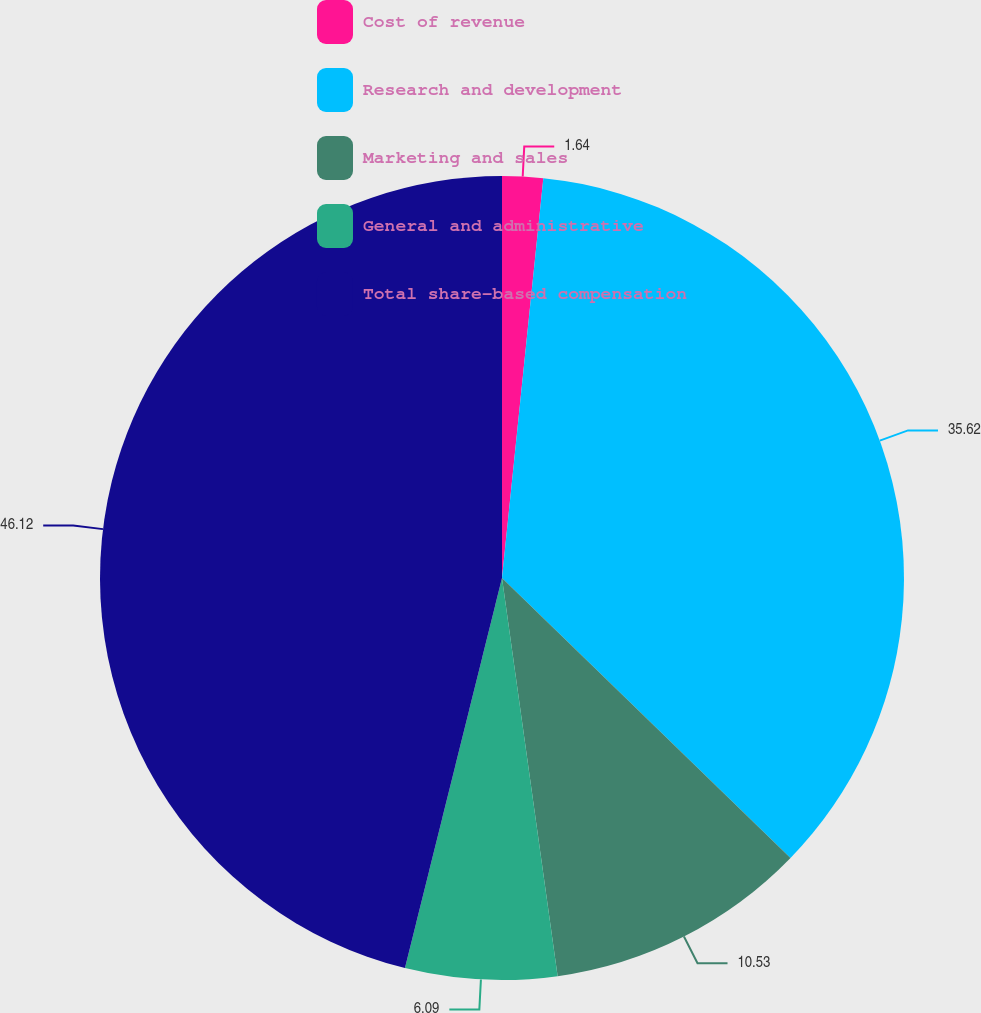<chart> <loc_0><loc_0><loc_500><loc_500><pie_chart><fcel>Cost of revenue<fcel>Research and development<fcel>Marketing and sales<fcel>General and administrative<fcel>Total share-based compensation<nl><fcel>1.64%<fcel>35.62%<fcel>10.53%<fcel>6.09%<fcel>46.12%<nl></chart> 